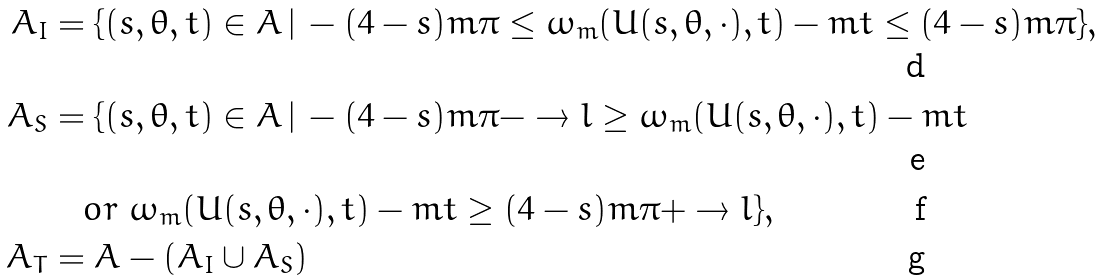<formula> <loc_0><loc_0><loc_500><loc_500>A _ { I } & = \{ ( s , \theta , t ) \in A \, | \, - ( 4 - s ) m \pi \leq \omega _ { m } ( U ( s , \theta , \cdot ) , t ) - m t \leq ( 4 - s ) m \pi \} , \\ A _ { S } & = \{ ( s , \theta , t ) \in A \, | \, - ( 4 - s ) m \pi - \to l \geq \omega _ { m } ( U ( s , \theta , \cdot ) , t ) - m t \\ & \quad o r \ \omega _ { m } ( U ( s , \theta , \cdot ) , t ) - m t \geq ( 4 - s ) m \pi + \to l \} , \\ A _ { T } & = A - ( A _ { I } \cup A _ { S } )</formula> 